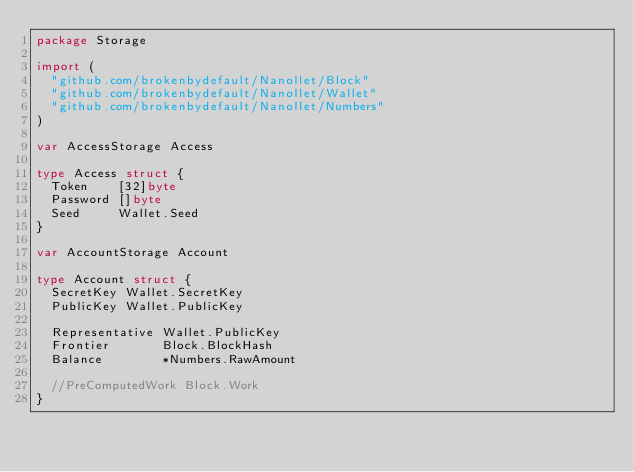<code> <loc_0><loc_0><loc_500><loc_500><_Go_>package Storage

import (
	"github.com/brokenbydefault/Nanollet/Block"
	"github.com/brokenbydefault/Nanollet/Wallet"
	"github.com/brokenbydefault/Nanollet/Numbers"
)

var AccessStorage Access

type Access struct {
	Token    [32]byte
	Password []byte
	Seed     Wallet.Seed
}

var AccountStorage Account

type Account struct {
	SecretKey Wallet.SecretKey
	PublicKey Wallet.PublicKey

	Representative Wallet.PublicKey
	Frontier       Block.BlockHash
	Balance        *Numbers.RawAmount

	//PreComputedWork Block.Work
}
</code> 